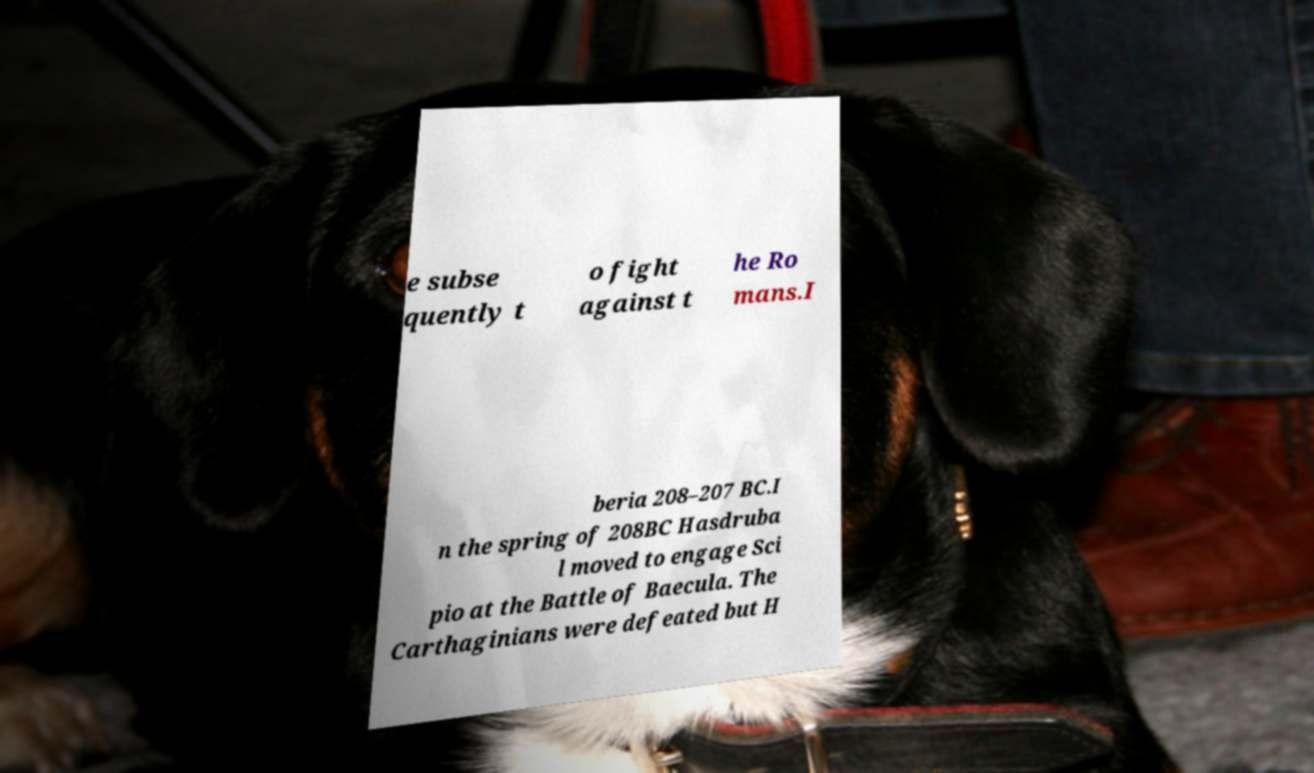Can you read and provide the text displayed in the image?This photo seems to have some interesting text. Can you extract and type it out for me? e subse quently t o fight against t he Ro mans.I beria 208–207 BC.I n the spring of 208BC Hasdruba l moved to engage Sci pio at the Battle of Baecula. The Carthaginians were defeated but H 